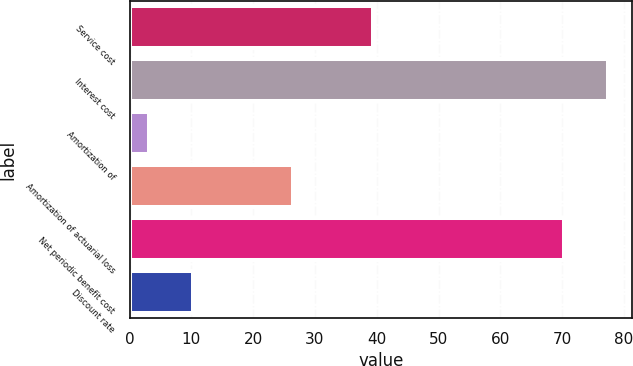<chart> <loc_0><loc_0><loc_500><loc_500><bar_chart><fcel>Service cost<fcel>Interest cost<fcel>Amortization of<fcel>Amortization of actuarial loss<fcel>Net periodic benefit cost<fcel>Discount rate<nl><fcel>39.4<fcel>77.43<fcel>3.2<fcel>26.4<fcel>70.3<fcel>10.33<nl></chart> 